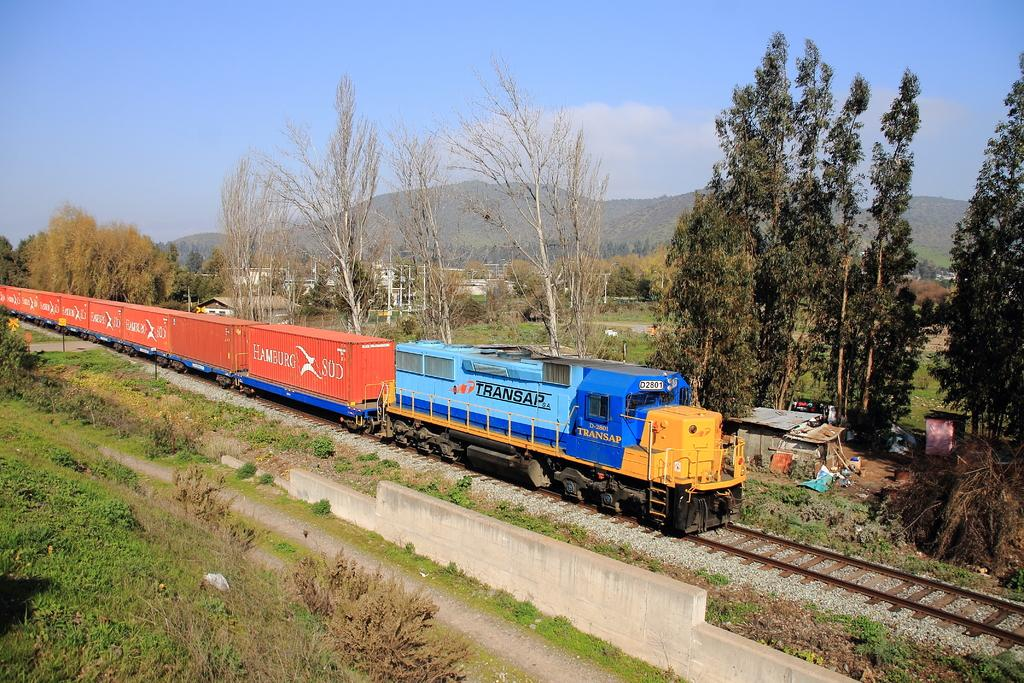What type of train is in the image? There is a goods train in the image. Where is the train located? The train is on a railway track. What can be seen on the sides of the railway track? There are plants on the sides of the railway track. What is visible in the background of the image? There are trees, hills, and the sky visible in the background of the image. What is written or displayed on the train? There is text or writing on the train. What type of notebook is being carried by the train in the image? There is no notebook present in the image. 